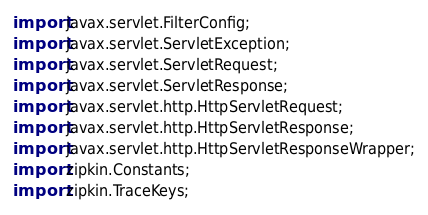<code> <loc_0><loc_0><loc_500><loc_500><_Java_>import javax.servlet.FilterConfig;
import javax.servlet.ServletException;
import javax.servlet.ServletRequest;
import javax.servlet.ServletResponse;
import javax.servlet.http.HttpServletRequest;
import javax.servlet.http.HttpServletResponse;
import javax.servlet.http.HttpServletResponseWrapper;
import zipkin.Constants;
import zipkin.TraceKeys;
</code> 